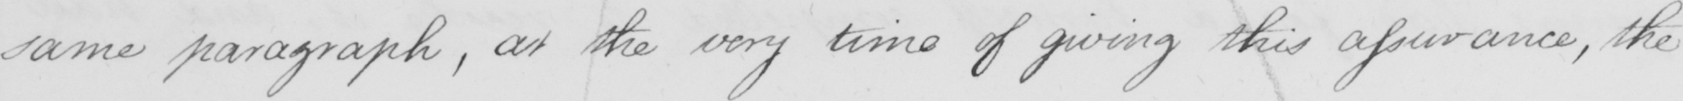What is written in this line of handwriting? same paragraph , at the very time of giving this assurance , the 